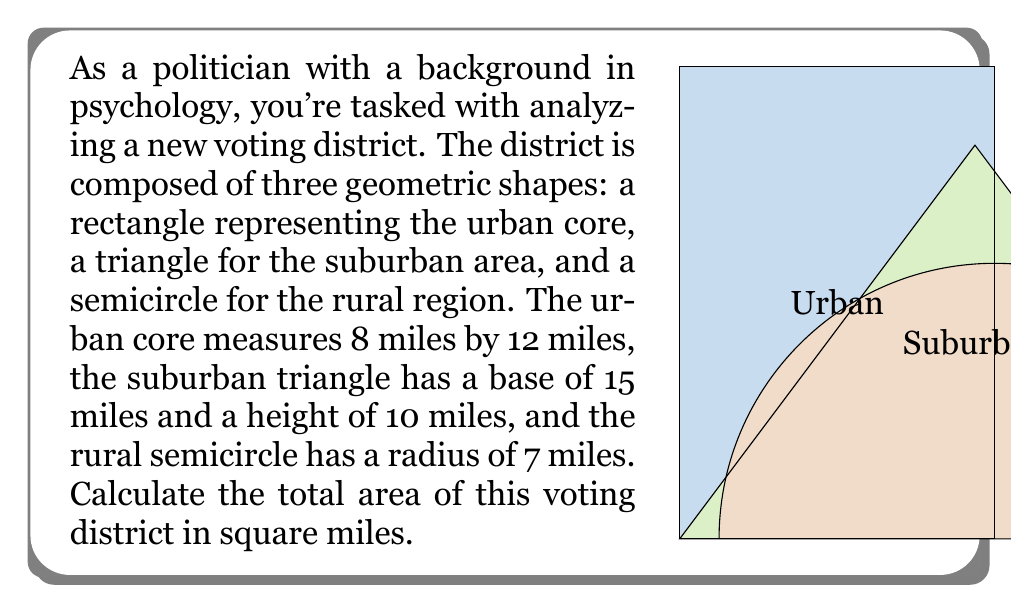Provide a solution to this math problem. To solve this problem, we need to calculate the area of each geometric shape and then sum them up. Let's break it down step-by-step:

1. Area of the rectangular urban core:
   $$ A_{rectangle} = length \times width = 8 \times 12 = 96 \text{ square miles} $$

2. Area of the triangular suburban region:
   $$ A_{triangle} = \frac{1}{2} \times base \times height = \frac{1}{2} \times 15 \times 10 = 75 \text{ square miles} $$

3. Area of the semicircular rural region:
   The area of a full circle is $\pi r^2$, so the area of a semicircle is half of that.
   $$ A_{semicircle} = \frac{1}{2} \times \pi r^2 = \frac{1}{2} \times \pi \times 7^2 = \frac{49\pi}{2} \text{ square miles} $$

4. Total area of the voting district:
   $$ A_{total} = A_{rectangle} + A_{triangle} + A_{semicircle} $$
   $$ A_{total} = 96 + 75 + \frac{49\pi}{2} $$
   $$ A_{total} = 171 + \frac{49\pi}{2} \text{ square miles} $$

To get a decimal approximation, we can use $\pi \approx 3.14159$:
$$ A_{total} \approx 171 + \frac{49 \times 3.14159}{2} \approx 247.95 \text{ square miles} $$
Answer: The total area of the voting district is $171 + \frac{49\pi}{2}$ square miles, or approximately 247.95 square miles. 